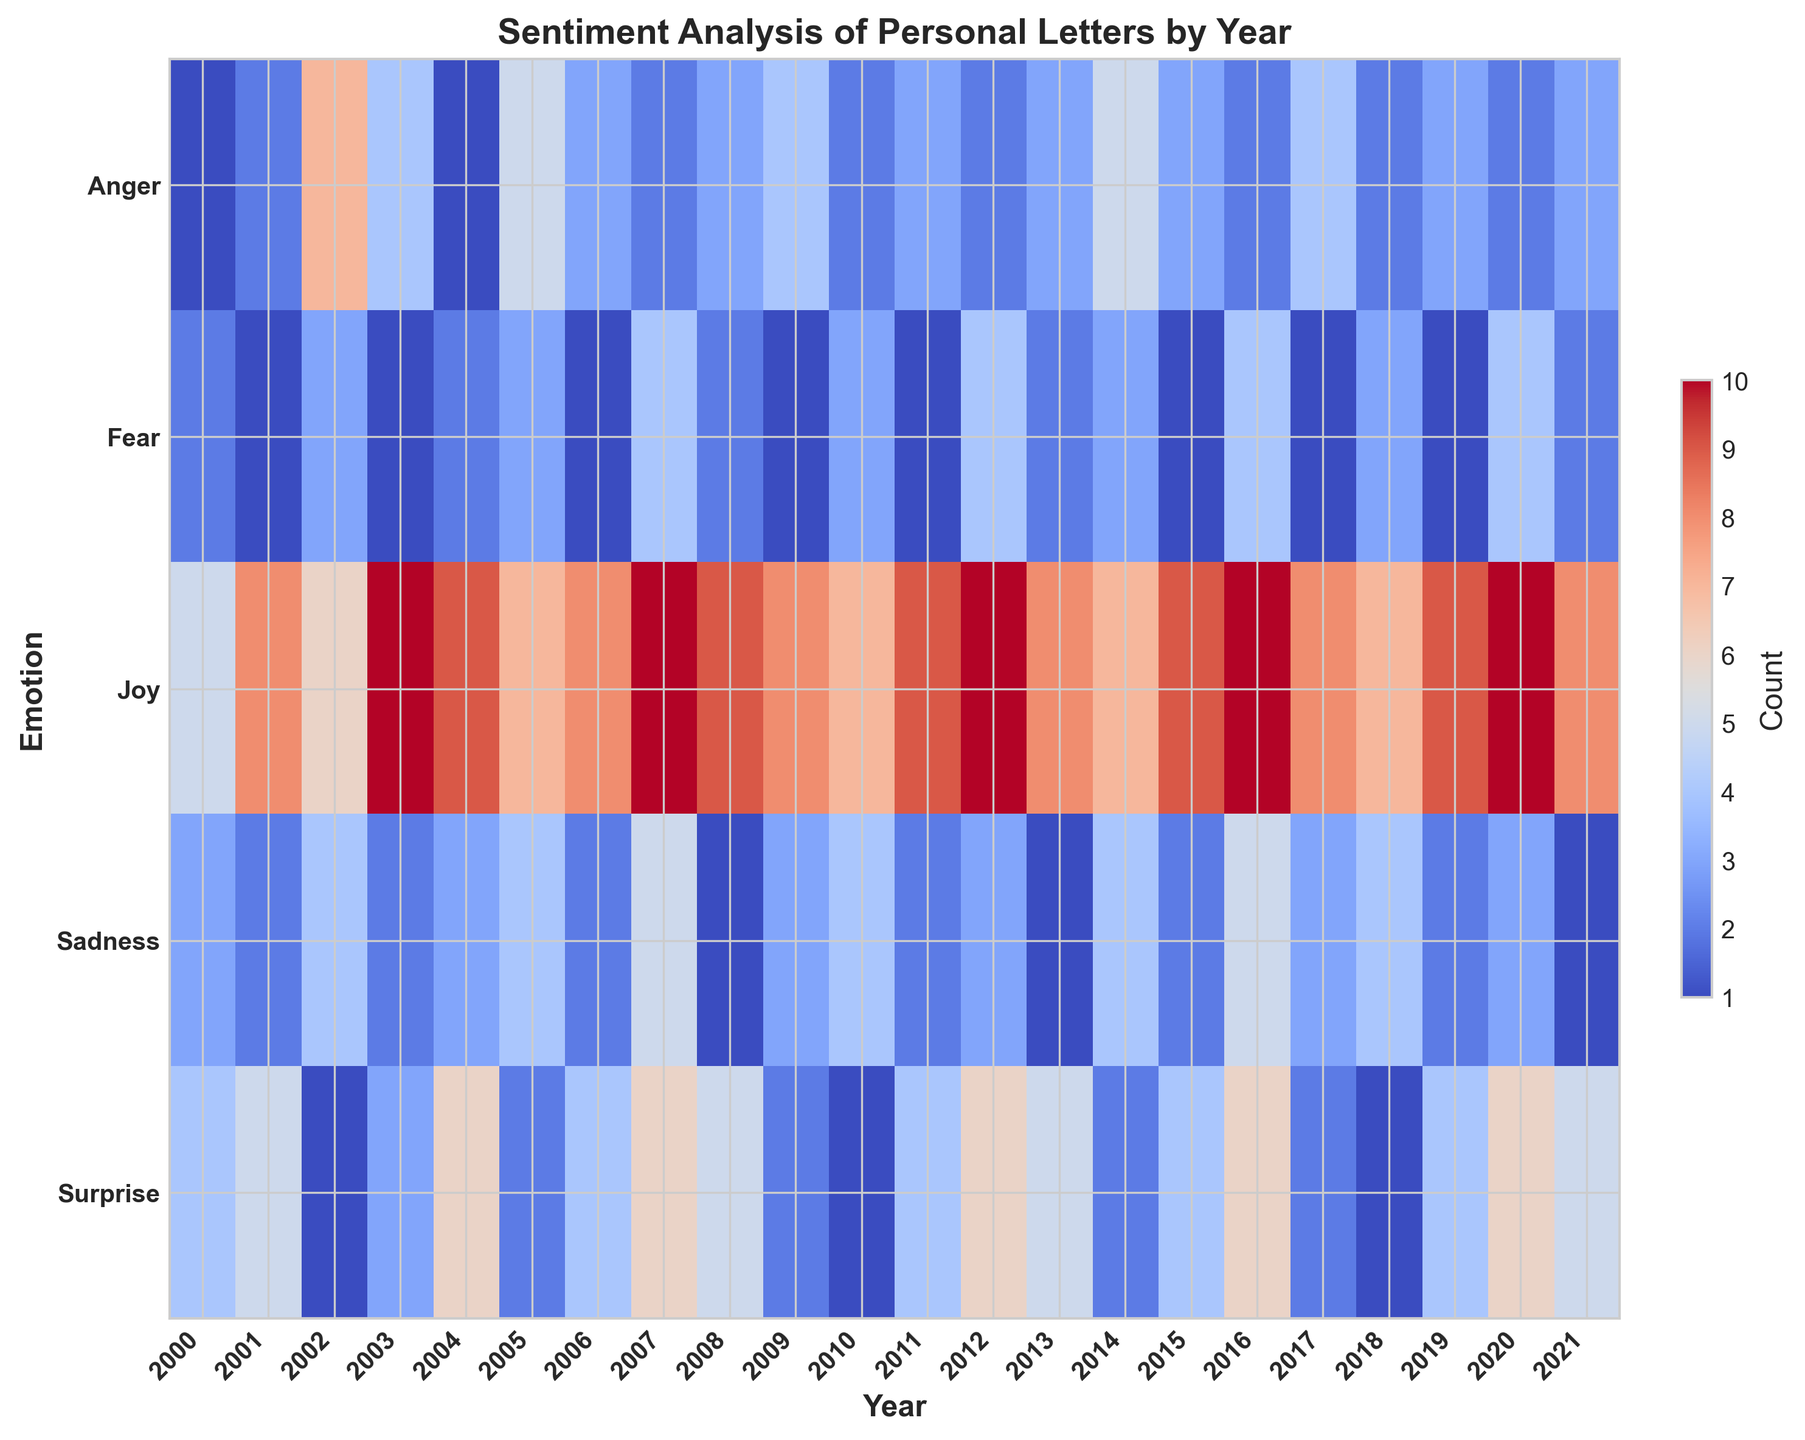Which year had the highest count of 'Joy' letters? Look at the 'Joy' row in the heatmap and identify the year with the most intense color (or the highest numerical value). The highest count of 'Joy' letters occurred in 2020, which corresponds to the highest number in that row.
Answer: 2020 Which emotion had the lowest count in 2009? Find the column for the year 2009 and look at the color intensities for each emotion. The emotion with the least intense color (or the smallest numerical value) is 'Fear' with a count of 1.
Answer: Fear How did the count of 'Anger' letters in 2002 compare to the count in 2007? Locate the 'Anger' row and compare the colors (or numerical values) for the years 2002 and 2007. The count for 'Anger' in 2002 is 7, while in 2007 it is 2, thus the count was higher in 2002.
Answer: Higher in 2002 Which year showed an equal count for both 'Sadness' and 'Surprise' letters? Go through the rows for 'Sadness' and 'Surprise' and find a year where both colors (or numerical values) match. For example, in 2009, both 'Sadness' and 'Surprise' have a count of 3 and 2 respectively.
Answer: 2009 What is the total count of 'Surprise' letters from 2000 to 2005? Sum the values in the 'Surprise' row from 2000 to 2005. The counts are 4, 5, 1, 3, 6, and 2 respectively. Adding them gives 4 + 5 + 1 + 3 + 6 + 2 = 21.
Answer: 21 Which year displayed the greatest variety of emotions based on counts? Examine the heatmap for years with a wide range of colors indicating different counts. The year with the most diverse color range (or highest variability in numerical values) typically has the greatest variety. 2007, for instance, has significant variation in emotional counts.
Answer: 2007 If the total count of 'Joy' letters from 2015 to 2020 is taken, what is the average per year? Add the 'Joy' counts from 2015 to 2020: 9 + 10 + 8 + 7 + 9 + 10. The sum is 53. To find the average over these 6 years, divide the sum by 6. The average is 53/6 = 8.83.
Answer: 8.83 